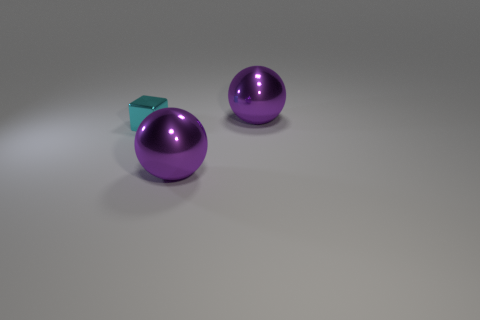Add 2 small cyan blocks. How many objects exist? 5 Subtract all blocks. How many objects are left? 2 Subtract all metal objects. Subtract all big cyan metallic cylinders. How many objects are left? 0 Add 1 tiny cyan objects. How many tiny cyan objects are left? 2 Add 1 big objects. How many big objects exist? 3 Subtract 0 red spheres. How many objects are left? 3 